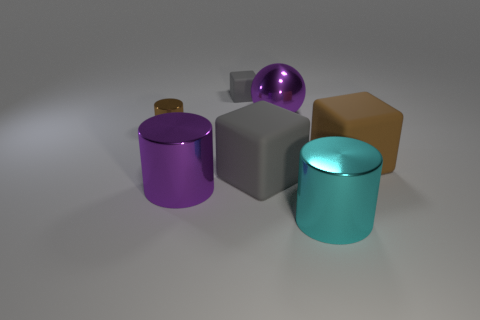What number of gray things are the same material as the small brown object? In the image, there are no gray objects that appear to be made of the same material as the small brown object, which seems to have a matte finish. The gray object has a metallic or shiny finish, indicative of a different material. 